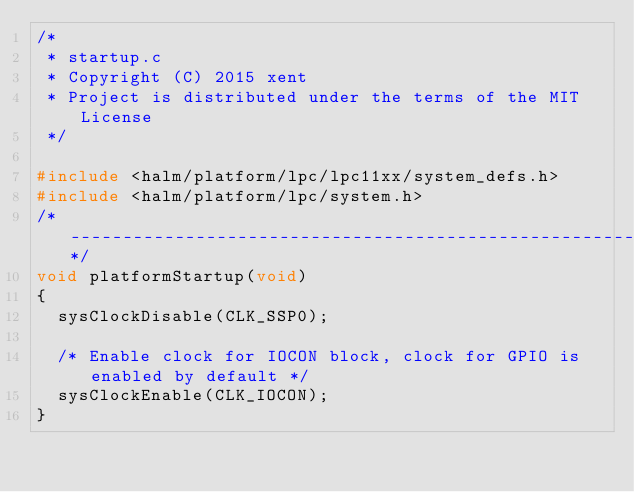<code> <loc_0><loc_0><loc_500><loc_500><_C_>/*
 * startup.c
 * Copyright (C) 2015 xent
 * Project is distributed under the terms of the MIT License
 */

#include <halm/platform/lpc/lpc11xx/system_defs.h>
#include <halm/platform/lpc/system.h>
/*----------------------------------------------------------------------------*/
void platformStartup(void)
{
  sysClockDisable(CLK_SSP0);

  /* Enable clock for IOCON block, clock for GPIO is enabled by default */
  sysClockEnable(CLK_IOCON);
}
</code> 